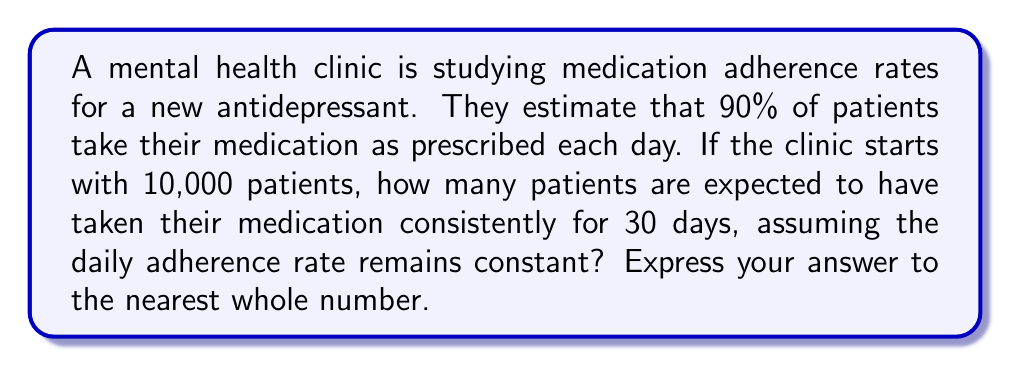Can you answer this question? Let's approach this step-by-step:

1) The daily adherence rate is 90% or 0.90.

2) We need to calculate the probability of a patient taking their medication consistently for 30 days.

3) This can be modeled as an exponential function:

   $$P(30) = (0.90)^{30}$$

   Where $P(30)$ is the probability of adhering to the medication regimen for 30 days.

4) Let's calculate this:

   $$P(30) = (0.90)^{30} \approx 0.0424$$

5) This means about 4.24% of patients are expected to adhere perfectly for 30 days.

6) With 10,000 initial patients, the number of fully adherent patients after 30 days would be:

   $$10,000 \times 0.0424 \approx 424$$

7) Rounding to the nearest whole number gives us 424 patients.
Answer: 424 patients 